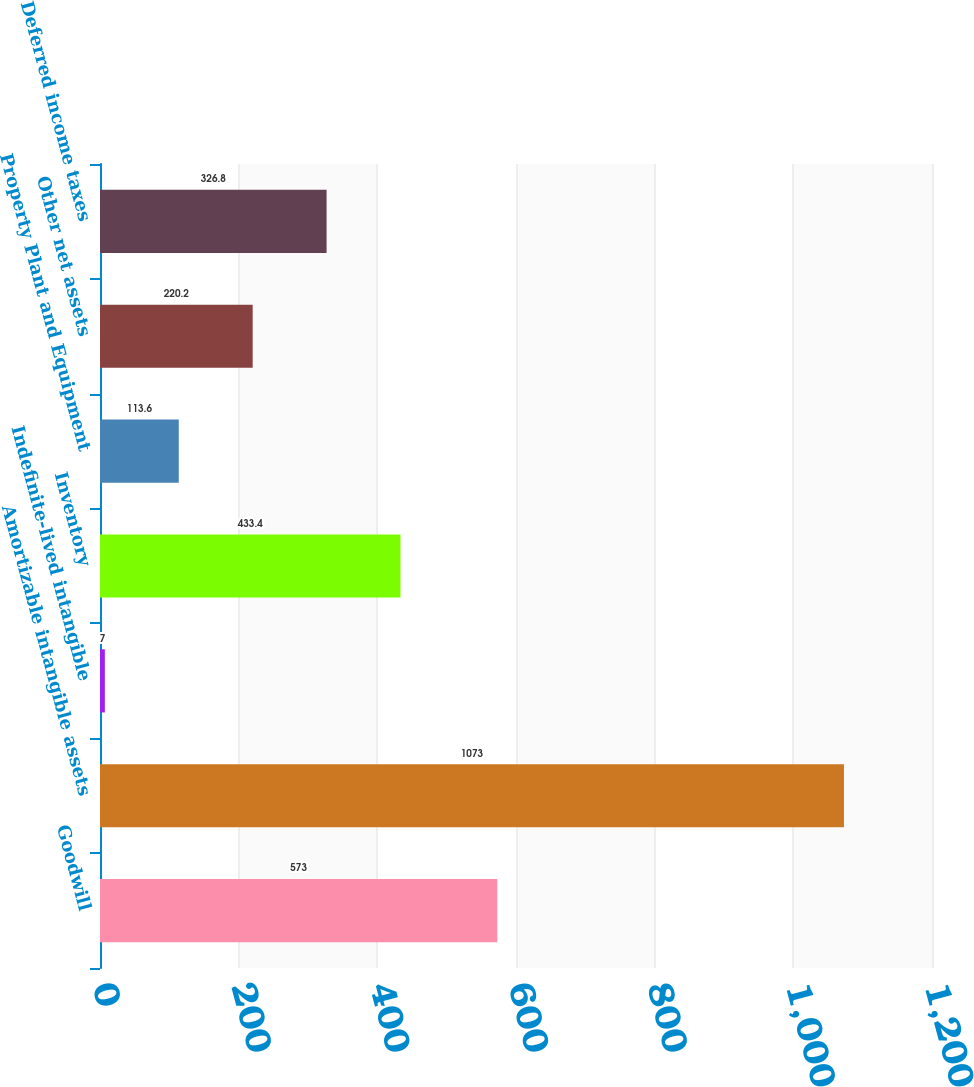Convert chart. <chart><loc_0><loc_0><loc_500><loc_500><bar_chart><fcel>Goodwill<fcel>Amortizable intangible assets<fcel>Indefinite-lived intangible<fcel>Inventory<fcel>Property Plant and Equipment<fcel>Other net assets<fcel>Deferred income taxes<nl><fcel>573<fcel>1073<fcel>7<fcel>433.4<fcel>113.6<fcel>220.2<fcel>326.8<nl></chart> 